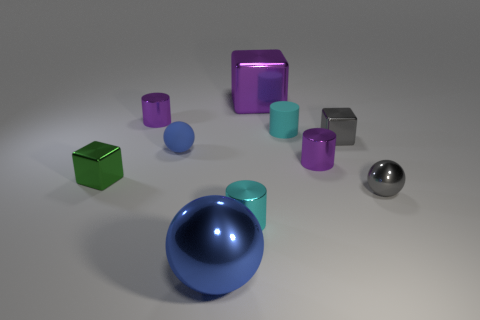Are there any rubber spheres of the same size as the green object?
Ensure brevity in your answer.  Yes. Is the size of the purple cylinder that is on the right side of the rubber cylinder the same as the green thing?
Your answer should be very brief. Yes. Is the number of big yellow metal objects greater than the number of blue rubber balls?
Your answer should be very brief. No. Is there a tiny green metallic thing that has the same shape as the cyan shiny object?
Your answer should be very brief. No. What shape is the big purple object behind the tiny gray cube?
Your answer should be compact. Cube. What number of purple cylinders are right of the shiny cylinder on the left side of the big blue metallic object that is in front of the small green metal block?
Make the answer very short. 1. There is a small block to the right of the big block; is its color the same as the tiny metallic ball?
Give a very brief answer. Yes. How many other objects are the same shape as the tiny cyan matte object?
Make the answer very short. 3. How many other objects are there of the same material as the gray sphere?
Offer a terse response. 7. What is the material of the purple thing that is in front of the small sphere behind the tiny gray thing in front of the green object?
Ensure brevity in your answer.  Metal. 